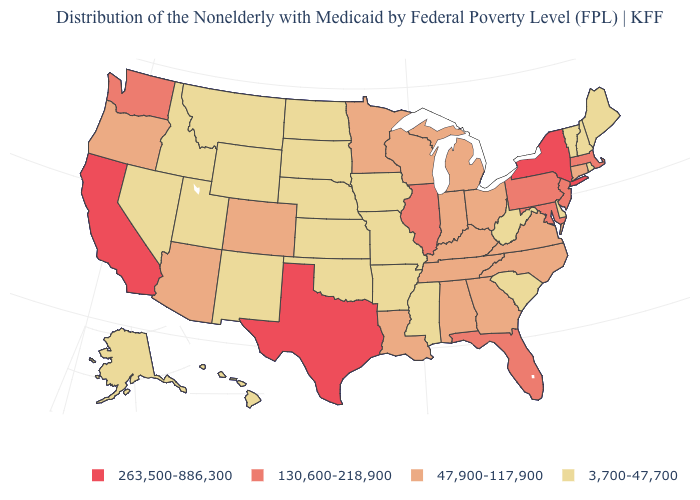Does Vermont have the lowest value in the USA?
Answer briefly. Yes. What is the value of Oklahoma?
Be succinct. 3,700-47,700. Name the states that have a value in the range 263,500-886,300?
Quick response, please. California, New York, Texas. Name the states that have a value in the range 3,700-47,700?
Answer briefly. Alaska, Arkansas, Delaware, Hawaii, Idaho, Iowa, Kansas, Maine, Mississippi, Missouri, Montana, Nebraska, Nevada, New Hampshire, New Mexico, North Dakota, Oklahoma, Rhode Island, South Carolina, South Dakota, Utah, Vermont, West Virginia, Wyoming. What is the value of Mississippi?
Be succinct. 3,700-47,700. Which states have the highest value in the USA?
Keep it brief. California, New York, Texas. Does Utah have the same value as Colorado?
Quick response, please. No. Name the states that have a value in the range 47,900-117,900?
Write a very short answer. Alabama, Arizona, Colorado, Connecticut, Georgia, Indiana, Kentucky, Louisiana, Michigan, Minnesota, North Carolina, Ohio, Oregon, Tennessee, Virginia, Wisconsin. Which states hav the highest value in the West?
Keep it brief. California. Name the states that have a value in the range 263,500-886,300?
Answer briefly. California, New York, Texas. Does California have the highest value in the West?
Give a very brief answer. Yes. Does Colorado have a lower value than New York?
Answer briefly. Yes. Which states hav the highest value in the South?
Write a very short answer. Texas. How many symbols are there in the legend?
Give a very brief answer. 4. 